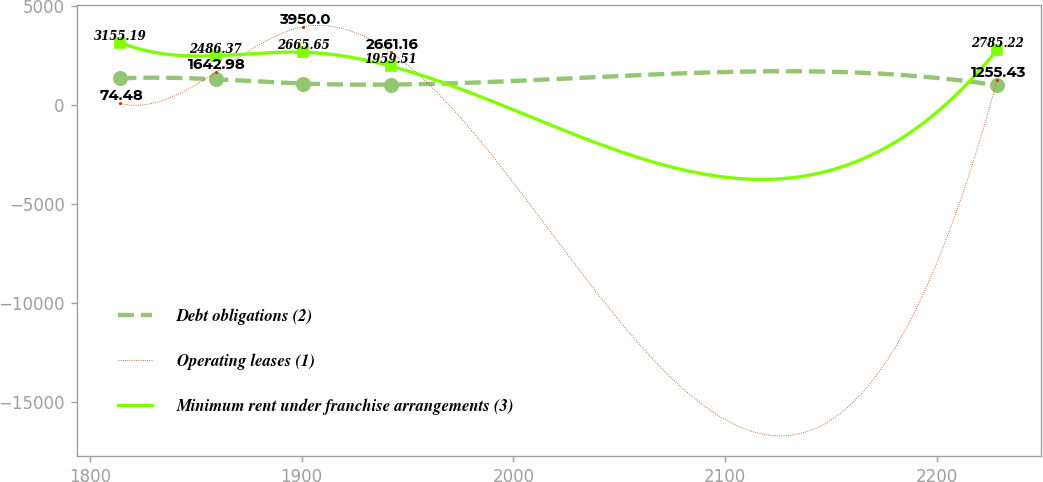Convert chart. <chart><loc_0><loc_0><loc_500><loc_500><line_chart><ecel><fcel>Debt obligations (2)<fcel>Operating leases (1)<fcel>Minimum rent under franchise arrangements (3)<nl><fcel>1814.44<fcel>1340.91<fcel>74.48<fcel>3155.19<nl><fcel>1859.38<fcel>1299.09<fcel>1642.98<fcel>2486.37<nl><fcel>1900.77<fcel>1083.9<fcel>3950<fcel>2665.65<nl><fcel>1942.16<fcel>1030.05<fcel>2661.16<fcel>1959.51<nl><fcel>2228.37<fcel>995.51<fcel>1255.43<fcel>2785.22<nl></chart> 